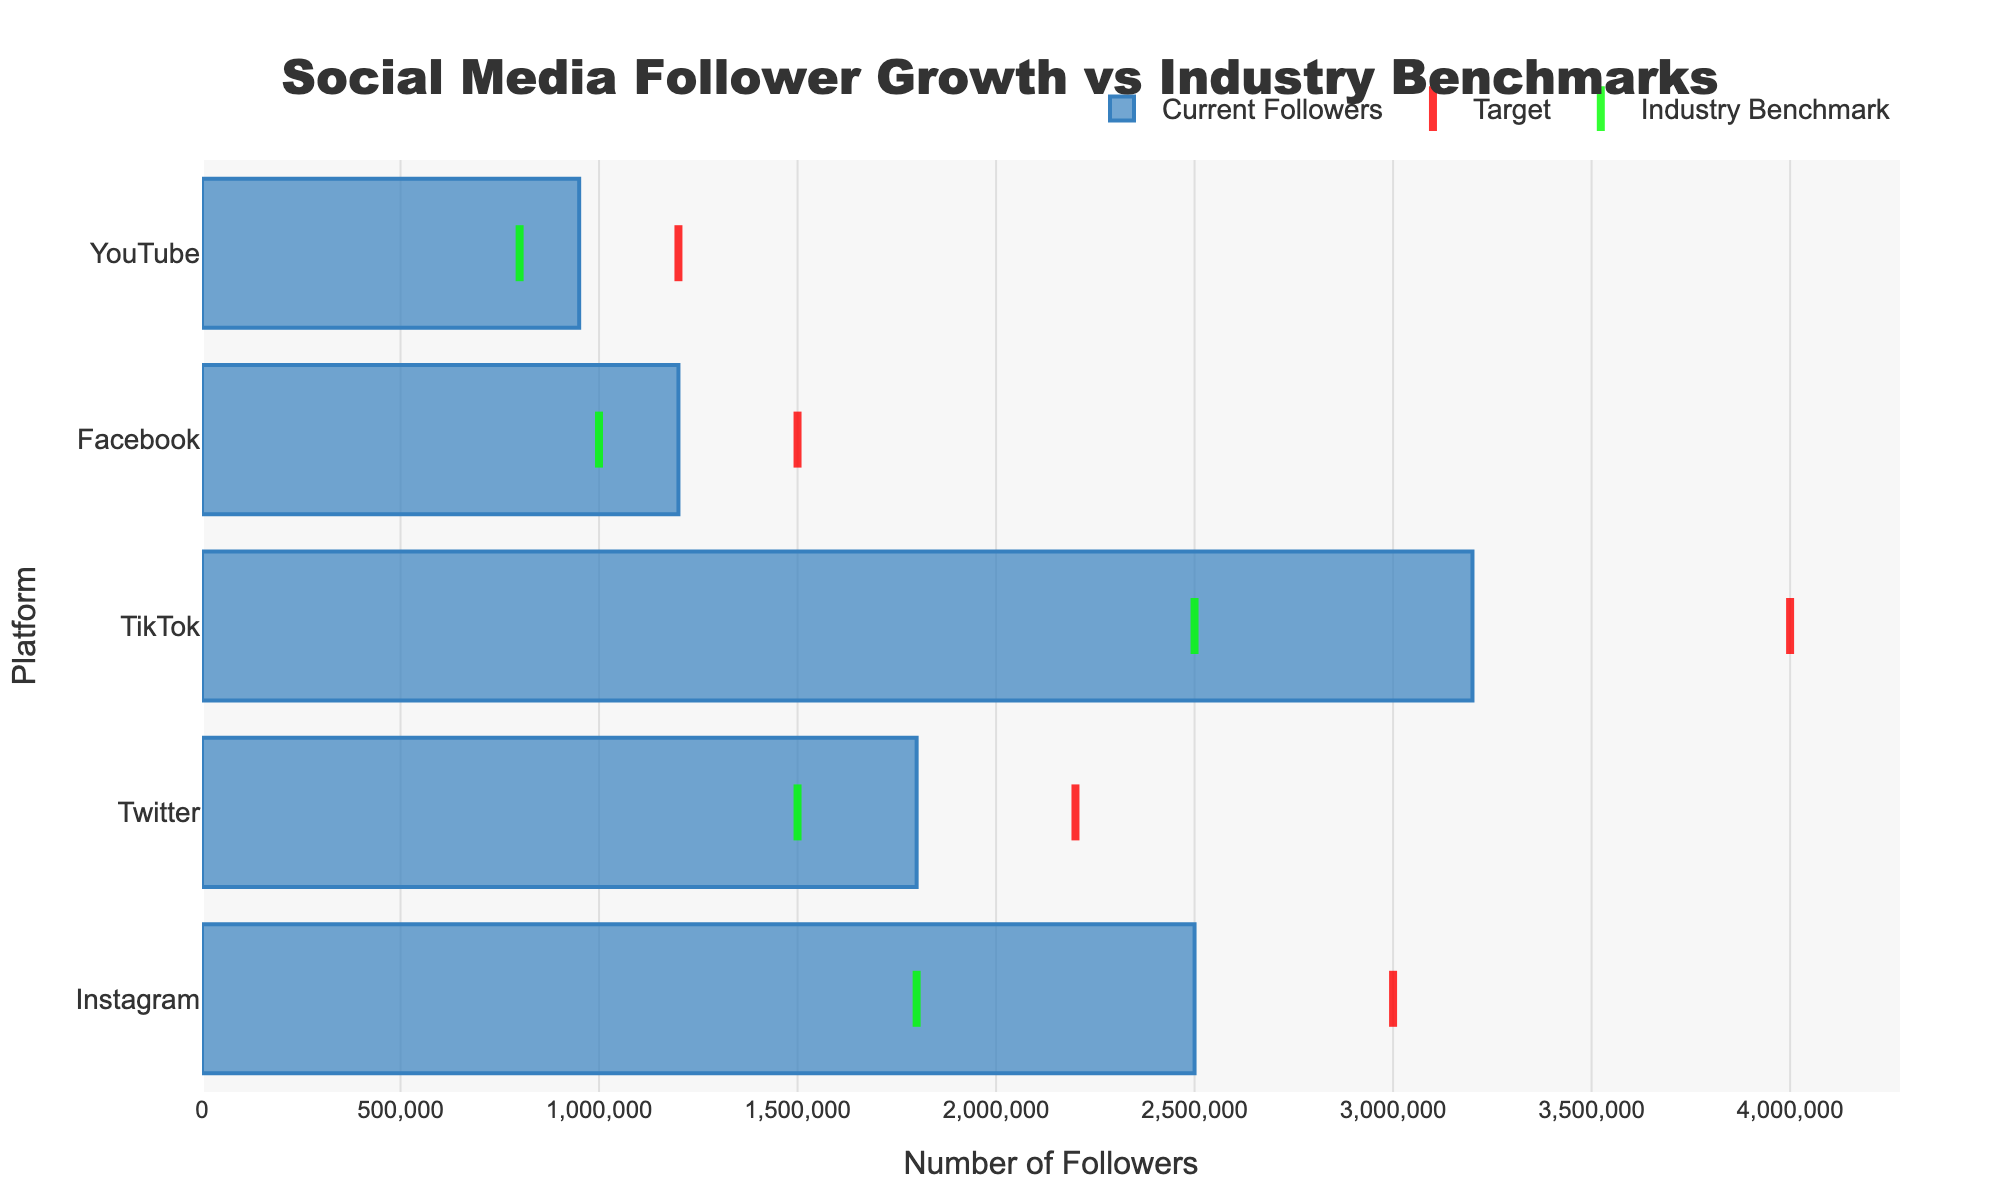What is the title of the chart? The title is usually placed at the top of the chart and conveys the main subject. In this case, the title reads "Social Media Follower Growth vs Industry Benchmarks".
Answer: Social Media Follower Growth vs Industry Benchmarks Which platform has the highest number of current followers? Look for the bar that extends the furthest to the right on the x-axis, representing the highest number of current followers. In this case, TikTok's bar reaches the farthest.
Answer: TikTok How many current followers does YouTube have? Locate the bar corresponding to YouTube and see its length on the x-axis, which denotes the number of current followers. YouTube has the shortest bar reaching up to 950,000 followers.
Answer: 950,000 What is the benchmark number of followers for Instagram? Locate the green dot (industry benchmark marker) aligned with Instagram and see the value on the x-axis.
Answer: 1,800,000 Which platform is closest to reaching its target followers? Compare the length of each bar (current followers) with its respective red marker (target). The smaller the gap, the closer it is. Instagram is closest to its target with 2,500,000 current followers out of a 3,000,000 target.
Answer: Instagram How many more followers does TikTok need to meet its target? Subtract the current followers (3,200,000) from the target number of followers (4,000,000). The difference is the number of additional followers needed: 4,000,000 - 3,200,000 = 800,000.
Answer: 800,000 Which platforms have current followers above the industry benchmark? Compare the length of the blue bars (current followers) to the position of the green markers (industry benchmarks). The platforms where the blue bar exceeds the green marker are Instagram, Twitter, TikTok, and Facebook.
Answer: Instagram, Twitter, TikTok, Facebook What is the total number of current followers across all platforms? Add the number of current followers for each platform: 2,500,000 (Instagram) + 1,800,000 (Twitter) + 3,200,000 (TikTok) + 1,200,000 (Facebook) + 950,000 (YouTube). This equals a total of 9,650,000.
Answer: 9,650,000 Which platform has the largest difference between its current followers and its industry benchmark? Calculate the difference for each platform and compare. The differences are Instagram (700,000), Twitter (300,000), TikTok (700,000), Facebook (200,000), and YouTube (150,000). TikTok and Instagram both have the largest differences of 700,000.
Answer: TikTok and Instagram 